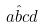<formula> <loc_0><loc_0><loc_500><loc_500>a \hat { b } c d</formula> 